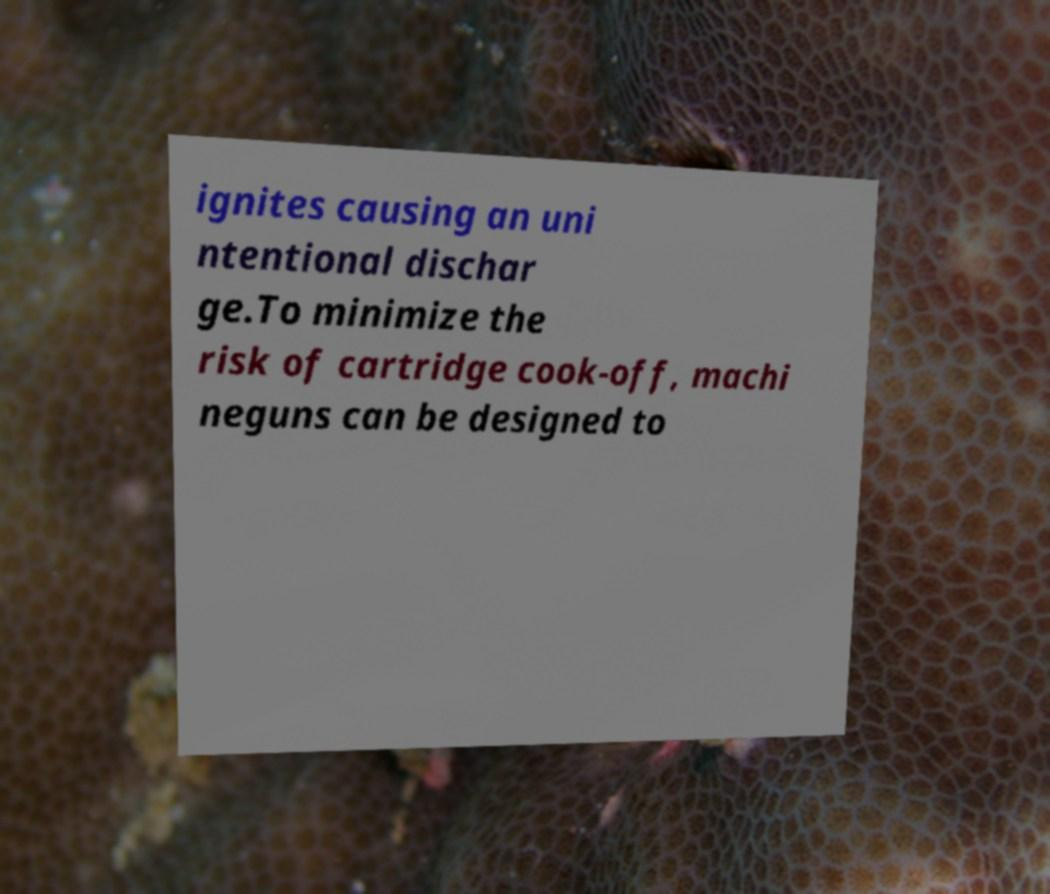Please identify and transcribe the text found in this image. ignites causing an uni ntentional dischar ge.To minimize the risk of cartridge cook-off, machi neguns can be designed to 